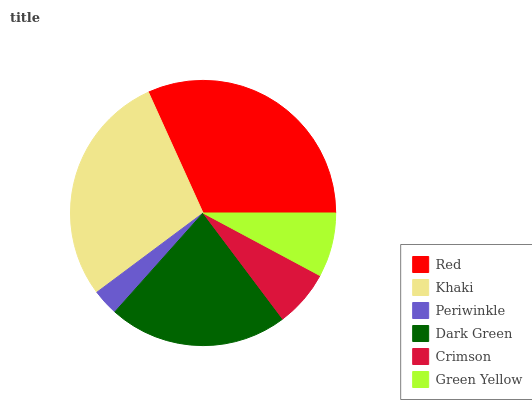Is Periwinkle the minimum?
Answer yes or no. Yes. Is Red the maximum?
Answer yes or no. Yes. Is Khaki the minimum?
Answer yes or no. No. Is Khaki the maximum?
Answer yes or no. No. Is Red greater than Khaki?
Answer yes or no. Yes. Is Khaki less than Red?
Answer yes or no. Yes. Is Khaki greater than Red?
Answer yes or no. No. Is Red less than Khaki?
Answer yes or no. No. Is Dark Green the high median?
Answer yes or no. Yes. Is Green Yellow the low median?
Answer yes or no. Yes. Is Khaki the high median?
Answer yes or no. No. Is Red the low median?
Answer yes or no. No. 